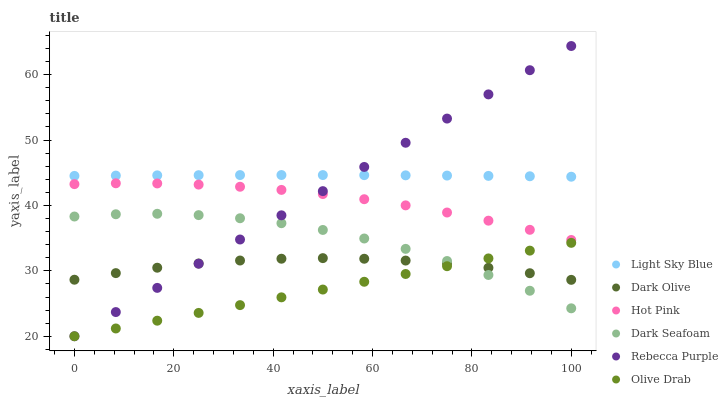Does Olive Drab have the minimum area under the curve?
Answer yes or no. Yes. Does Light Sky Blue have the maximum area under the curve?
Answer yes or no. Yes. Does Dark Olive have the minimum area under the curve?
Answer yes or no. No. Does Dark Olive have the maximum area under the curve?
Answer yes or no. No. Is Olive Drab the smoothest?
Answer yes or no. Yes. Is Dark Seafoam the roughest?
Answer yes or no. Yes. Is Dark Olive the smoothest?
Answer yes or no. No. Is Dark Olive the roughest?
Answer yes or no. No. Does Rebecca Purple have the lowest value?
Answer yes or no. Yes. Does Dark Olive have the lowest value?
Answer yes or no. No. Does Rebecca Purple have the highest value?
Answer yes or no. Yes. Does Dark Seafoam have the highest value?
Answer yes or no. No. Is Dark Olive less than Hot Pink?
Answer yes or no. Yes. Is Light Sky Blue greater than Dark Seafoam?
Answer yes or no. Yes. Does Rebecca Purple intersect Dark Seafoam?
Answer yes or no. Yes. Is Rebecca Purple less than Dark Seafoam?
Answer yes or no. No. Is Rebecca Purple greater than Dark Seafoam?
Answer yes or no. No. Does Dark Olive intersect Hot Pink?
Answer yes or no. No. 